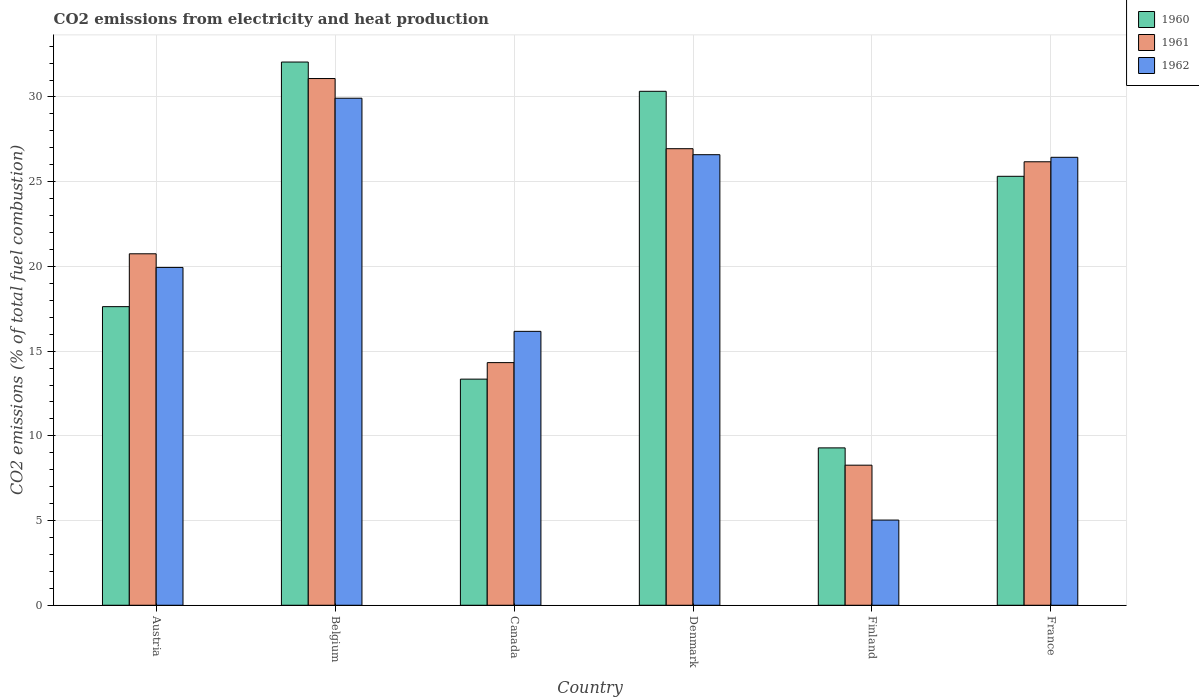How many groups of bars are there?
Make the answer very short. 6. Are the number of bars per tick equal to the number of legend labels?
Make the answer very short. Yes. How many bars are there on the 1st tick from the left?
Give a very brief answer. 3. How many bars are there on the 1st tick from the right?
Ensure brevity in your answer.  3. What is the amount of CO2 emitted in 1960 in Belgium?
Keep it short and to the point. 32.06. Across all countries, what is the maximum amount of CO2 emitted in 1962?
Offer a very short reply. 29.93. Across all countries, what is the minimum amount of CO2 emitted in 1960?
Provide a succinct answer. 9.29. What is the total amount of CO2 emitted in 1960 in the graph?
Offer a very short reply. 127.98. What is the difference between the amount of CO2 emitted in 1961 in Denmark and that in France?
Your answer should be very brief. 0.77. What is the difference between the amount of CO2 emitted in 1960 in Austria and the amount of CO2 emitted in 1961 in Belgium?
Give a very brief answer. -13.46. What is the average amount of CO2 emitted in 1962 per country?
Your response must be concise. 20.68. What is the difference between the amount of CO2 emitted of/in 1961 and amount of CO2 emitted of/in 1960 in Belgium?
Make the answer very short. -0.97. What is the ratio of the amount of CO2 emitted in 1960 in Canada to that in Finland?
Offer a terse response. 1.44. Is the amount of CO2 emitted in 1960 in Canada less than that in France?
Make the answer very short. Yes. What is the difference between the highest and the second highest amount of CO2 emitted in 1961?
Provide a succinct answer. 0.77. What is the difference between the highest and the lowest amount of CO2 emitted in 1961?
Offer a terse response. 22.82. What does the 1st bar from the left in Canada represents?
Your response must be concise. 1960. How many bars are there?
Your answer should be compact. 18. Are all the bars in the graph horizontal?
Your answer should be compact. No. Where does the legend appear in the graph?
Keep it short and to the point. Top right. How are the legend labels stacked?
Your answer should be very brief. Vertical. What is the title of the graph?
Offer a terse response. CO2 emissions from electricity and heat production. What is the label or title of the Y-axis?
Give a very brief answer. CO2 emissions (% of total fuel combustion). What is the CO2 emissions (% of total fuel combustion) in 1960 in Austria?
Provide a short and direct response. 17.63. What is the CO2 emissions (% of total fuel combustion) in 1961 in Austria?
Provide a short and direct response. 20.75. What is the CO2 emissions (% of total fuel combustion) of 1962 in Austria?
Ensure brevity in your answer.  19.94. What is the CO2 emissions (% of total fuel combustion) in 1960 in Belgium?
Ensure brevity in your answer.  32.06. What is the CO2 emissions (% of total fuel combustion) in 1961 in Belgium?
Give a very brief answer. 31.09. What is the CO2 emissions (% of total fuel combustion) of 1962 in Belgium?
Keep it short and to the point. 29.93. What is the CO2 emissions (% of total fuel combustion) in 1960 in Canada?
Your answer should be very brief. 13.35. What is the CO2 emissions (% of total fuel combustion) of 1961 in Canada?
Your response must be concise. 14.32. What is the CO2 emissions (% of total fuel combustion) in 1962 in Canada?
Your response must be concise. 16.17. What is the CO2 emissions (% of total fuel combustion) of 1960 in Denmark?
Provide a short and direct response. 30.34. What is the CO2 emissions (% of total fuel combustion) in 1961 in Denmark?
Give a very brief answer. 26.95. What is the CO2 emissions (% of total fuel combustion) of 1962 in Denmark?
Offer a terse response. 26.59. What is the CO2 emissions (% of total fuel combustion) in 1960 in Finland?
Offer a terse response. 9.29. What is the CO2 emissions (% of total fuel combustion) of 1961 in Finland?
Provide a succinct answer. 8.27. What is the CO2 emissions (% of total fuel combustion) of 1962 in Finland?
Ensure brevity in your answer.  5.03. What is the CO2 emissions (% of total fuel combustion) in 1960 in France?
Provide a succinct answer. 25.32. What is the CO2 emissions (% of total fuel combustion) of 1961 in France?
Offer a terse response. 26.18. What is the CO2 emissions (% of total fuel combustion) of 1962 in France?
Your answer should be compact. 26.44. Across all countries, what is the maximum CO2 emissions (% of total fuel combustion) of 1960?
Your response must be concise. 32.06. Across all countries, what is the maximum CO2 emissions (% of total fuel combustion) of 1961?
Your response must be concise. 31.09. Across all countries, what is the maximum CO2 emissions (% of total fuel combustion) in 1962?
Make the answer very short. 29.93. Across all countries, what is the minimum CO2 emissions (% of total fuel combustion) of 1960?
Keep it short and to the point. 9.29. Across all countries, what is the minimum CO2 emissions (% of total fuel combustion) in 1961?
Provide a short and direct response. 8.27. Across all countries, what is the minimum CO2 emissions (% of total fuel combustion) of 1962?
Your response must be concise. 5.03. What is the total CO2 emissions (% of total fuel combustion) in 1960 in the graph?
Your response must be concise. 127.98. What is the total CO2 emissions (% of total fuel combustion) in 1961 in the graph?
Offer a terse response. 127.55. What is the total CO2 emissions (% of total fuel combustion) in 1962 in the graph?
Offer a terse response. 124.1. What is the difference between the CO2 emissions (% of total fuel combustion) in 1960 in Austria and that in Belgium?
Your response must be concise. -14.44. What is the difference between the CO2 emissions (% of total fuel combustion) in 1961 in Austria and that in Belgium?
Your answer should be compact. -10.34. What is the difference between the CO2 emissions (% of total fuel combustion) in 1962 in Austria and that in Belgium?
Give a very brief answer. -9.99. What is the difference between the CO2 emissions (% of total fuel combustion) in 1960 in Austria and that in Canada?
Your answer should be compact. 4.28. What is the difference between the CO2 emissions (% of total fuel combustion) in 1961 in Austria and that in Canada?
Keep it short and to the point. 6.42. What is the difference between the CO2 emissions (% of total fuel combustion) in 1962 in Austria and that in Canada?
Ensure brevity in your answer.  3.77. What is the difference between the CO2 emissions (% of total fuel combustion) in 1960 in Austria and that in Denmark?
Give a very brief answer. -12.71. What is the difference between the CO2 emissions (% of total fuel combustion) in 1961 in Austria and that in Denmark?
Ensure brevity in your answer.  -6.2. What is the difference between the CO2 emissions (% of total fuel combustion) of 1962 in Austria and that in Denmark?
Your answer should be compact. -6.65. What is the difference between the CO2 emissions (% of total fuel combustion) in 1960 in Austria and that in Finland?
Make the answer very short. 8.34. What is the difference between the CO2 emissions (% of total fuel combustion) of 1961 in Austria and that in Finland?
Give a very brief answer. 12.48. What is the difference between the CO2 emissions (% of total fuel combustion) in 1962 in Austria and that in Finland?
Your answer should be compact. 14.91. What is the difference between the CO2 emissions (% of total fuel combustion) in 1960 in Austria and that in France?
Provide a succinct answer. -7.69. What is the difference between the CO2 emissions (% of total fuel combustion) of 1961 in Austria and that in France?
Keep it short and to the point. -5.43. What is the difference between the CO2 emissions (% of total fuel combustion) of 1962 in Austria and that in France?
Make the answer very short. -6.5. What is the difference between the CO2 emissions (% of total fuel combustion) of 1960 in Belgium and that in Canada?
Provide a succinct answer. 18.72. What is the difference between the CO2 emissions (% of total fuel combustion) in 1961 in Belgium and that in Canada?
Offer a very short reply. 16.77. What is the difference between the CO2 emissions (% of total fuel combustion) in 1962 in Belgium and that in Canada?
Provide a short and direct response. 13.76. What is the difference between the CO2 emissions (% of total fuel combustion) of 1960 in Belgium and that in Denmark?
Keep it short and to the point. 1.73. What is the difference between the CO2 emissions (% of total fuel combustion) in 1961 in Belgium and that in Denmark?
Keep it short and to the point. 4.14. What is the difference between the CO2 emissions (% of total fuel combustion) in 1962 in Belgium and that in Denmark?
Your response must be concise. 3.33. What is the difference between the CO2 emissions (% of total fuel combustion) of 1960 in Belgium and that in Finland?
Make the answer very short. 22.77. What is the difference between the CO2 emissions (% of total fuel combustion) in 1961 in Belgium and that in Finland?
Provide a short and direct response. 22.82. What is the difference between the CO2 emissions (% of total fuel combustion) of 1962 in Belgium and that in Finland?
Ensure brevity in your answer.  24.9. What is the difference between the CO2 emissions (% of total fuel combustion) of 1960 in Belgium and that in France?
Provide a succinct answer. 6.74. What is the difference between the CO2 emissions (% of total fuel combustion) in 1961 in Belgium and that in France?
Offer a terse response. 4.91. What is the difference between the CO2 emissions (% of total fuel combustion) in 1962 in Belgium and that in France?
Make the answer very short. 3.49. What is the difference between the CO2 emissions (% of total fuel combustion) of 1960 in Canada and that in Denmark?
Keep it short and to the point. -16.99. What is the difference between the CO2 emissions (% of total fuel combustion) in 1961 in Canada and that in Denmark?
Your response must be concise. -12.63. What is the difference between the CO2 emissions (% of total fuel combustion) in 1962 in Canada and that in Denmark?
Provide a short and direct response. -10.43. What is the difference between the CO2 emissions (% of total fuel combustion) of 1960 in Canada and that in Finland?
Give a very brief answer. 4.06. What is the difference between the CO2 emissions (% of total fuel combustion) of 1961 in Canada and that in Finland?
Make the answer very short. 6.05. What is the difference between the CO2 emissions (% of total fuel combustion) of 1962 in Canada and that in Finland?
Your answer should be compact. 11.14. What is the difference between the CO2 emissions (% of total fuel combustion) in 1960 in Canada and that in France?
Your response must be concise. -11.97. What is the difference between the CO2 emissions (% of total fuel combustion) in 1961 in Canada and that in France?
Your answer should be compact. -11.85. What is the difference between the CO2 emissions (% of total fuel combustion) in 1962 in Canada and that in France?
Your response must be concise. -10.27. What is the difference between the CO2 emissions (% of total fuel combustion) of 1960 in Denmark and that in Finland?
Your response must be concise. 21.05. What is the difference between the CO2 emissions (% of total fuel combustion) in 1961 in Denmark and that in Finland?
Make the answer very short. 18.68. What is the difference between the CO2 emissions (% of total fuel combustion) of 1962 in Denmark and that in Finland?
Offer a very short reply. 21.57. What is the difference between the CO2 emissions (% of total fuel combustion) of 1960 in Denmark and that in France?
Offer a terse response. 5.02. What is the difference between the CO2 emissions (% of total fuel combustion) of 1961 in Denmark and that in France?
Your answer should be very brief. 0.77. What is the difference between the CO2 emissions (% of total fuel combustion) of 1962 in Denmark and that in France?
Your answer should be compact. 0.15. What is the difference between the CO2 emissions (% of total fuel combustion) in 1960 in Finland and that in France?
Your answer should be compact. -16.03. What is the difference between the CO2 emissions (% of total fuel combustion) of 1961 in Finland and that in France?
Your answer should be very brief. -17.91. What is the difference between the CO2 emissions (% of total fuel combustion) of 1962 in Finland and that in France?
Ensure brevity in your answer.  -21.41. What is the difference between the CO2 emissions (% of total fuel combustion) of 1960 in Austria and the CO2 emissions (% of total fuel combustion) of 1961 in Belgium?
Give a very brief answer. -13.46. What is the difference between the CO2 emissions (% of total fuel combustion) of 1960 in Austria and the CO2 emissions (% of total fuel combustion) of 1962 in Belgium?
Give a very brief answer. -12.3. What is the difference between the CO2 emissions (% of total fuel combustion) in 1961 in Austria and the CO2 emissions (% of total fuel combustion) in 1962 in Belgium?
Keep it short and to the point. -9.18. What is the difference between the CO2 emissions (% of total fuel combustion) of 1960 in Austria and the CO2 emissions (% of total fuel combustion) of 1961 in Canada?
Your response must be concise. 3.3. What is the difference between the CO2 emissions (% of total fuel combustion) in 1960 in Austria and the CO2 emissions (% of total fuel combustion) in 1962 in Canada?
Make the answer very short. 1.46. What is the difference between the CO2 emissions (% of total fuel combustion) in 1961 in Austria and the CO2 emissions (% of total fuel combustion) in 1962 in Canada?
Keep it short and to the point. 4.58. What is the difference between the CO2 emissions (% of total fuel combustion) in 1960 in Austria and the CO2 emissions (% of total fuel combustion) in 1961 in Denmark?
Your answer should be compact. -9.32. What is the difference between the CO2 emissions (% of total fuel combustion) of 1960 in Austria and the CO2 emissions (% of total fuel combustion) of 1962 in Denmark?
Provide a short and direct response. -8.97. What is the difference between the CO2 emissions (% of total fuel combustion) in 1961 in Austria and the CO2 emissions (% of total fuel combustion) in 1962 in Denmark?
Your response must be concise. -5.85. What is the difference between the CO2 emissions (% of total fuel combustion) of 1960 in Austria and the CO2 emissions (% of total fuel combustion) of 1961 in Finland?
Offer a very short reply. 9.36. What is the difference between the CO2 emissions (% of total fuel combustion) in 1960 in Austria and the CO2 emissions (% of total fuel combustion) in 1962 in Finland?
Offer a terse response. 12.6. What is the difference between the CO2 emissions (% of total fuel combustion) of 1961 in Austria and the CO2 emissions (% of total fuel combustion) of 1962 in Finland?
Make the answer very short. 15.72. What is the difference between the CO2 emissions (% of total fuel combustion) of 1960 in Austria and the CO2 emissions (% of total fuel combustion) of 1961 in France?
Your answer should be compact. -8.55. What is the difference between the CO2 emissions (% of total fuel combustion) in 1960 in Austria and the CO2 emissions (% of total fuel combustion) in 1962 in France?
Give a very brief answer. -8.81. What is the difference between the CO2 emissions (% of total fuel combustion) of 1961 in Austria and the CO2 emissions (% of total fuel combustion) of 1962 in France?
Make the answer very short. -5.69. What is the difference between the CO2 emissions (% of total fuel combustion) in 1960 in Belgium and the CO2 emissions (% of total fuel combustion) in 1961 in Canada?
Keep it short and to the point. 17.74. What is the difference between the CO2 emissions (% of total fuel combustion) in 1960 in Belgium and the CO2 emissions (% of total fuel combustion) in 1962 in Canada?
Ensure brevity in your answer.  15.9. What is the difference between the CO2 emissions (% of total fuel combustion) of 1961 in Belgium and the CO2 emissions (% of total fuel combustion) of 1962 in Canada?
Offer a terse response. 14.92. What is the difference between the CO2 emissions (% of total fuel combustion) in 1960 in Belgium and the CO2 emissions (% of total fuel combustion) in 1961 in Denmark?
Your response must be concise. 5.11. What is the difference between the CO2 emissions (% of total fuel combustion) of 1960 in Belgium and the CO2 emissions (% of total fuel combustion) of 1962 in Denmark?
Your response must be concise. 5.47. What is the difference between the CO2 emissions (% of total fuel combustion) of 1961 in Belgium and the CO2 emissions (% of total fuel combustion) of 1962 in Denmark?
Your answer should be compact. 4.5. What is the difference between the CO2 emissions (% of total fuel combustion) in 1960 in Belgium and the CO2 emissions (% of total fuel combustion) in 1961 in Finland?
Your answer should be compact. 23.79. What is the difference between the CO2 emissions (% of total fuel combustion) of 1960 in Belgium and the CO2 emissions (% of total fuel combustion) of 1962 in Finland?
Give a very brief answer. 27.04. What is the difference between the CO2 emissions (% of total fuel combustion) of 1961 in Belgium and the CO2 emissions (% of total fuel combustion) of 1962 in Finland?
Ensure brevity in your answer.  26.06. What is the difference between the CO2 emissions (% of total fuel combustion) of 1960 in Belgium and the CO2 emissions (% of total fuel combustion) of 1961 in France?
Your answer should be very brief. 5.89. What is the difference between the CO2 emissions (% of total fuel combustion) of 1960 in Belgium and the CO2 emissions (% of total fuel combustion) of 1962 in France?
Provide a succinct answer. 5.62. What is the difference between the CO2 emissions (% of total fuel combustion) of 1961 in Belgium and the CO2 emissions (% of total fuel combustion) of 1962 in France?
Your response must be concise. 4.65. What is the difference between the CO2 emissions (% of total fuel combustion) of 1960 in Canada and the CO2 emissions (% of total fuel combustion) of 1961 in Denmark?
Offer a terse response. -13.6. What is the difference between the CO2 emissions (% of total fuel combustion) in 1960 in Canada and the CO2 emissions (% of total fuel combustion) in 1962 in Denmark?
Provide a short and direct response. -13.25. What is the difference between the CO2 emissions (% of total fuel combustion) in 1961 in Canada and the CO2 emissions (% of total fuel combustion) in 1962 in Denmark?
Give a very brief answer. -12.27. What is the difference between the CO2 emissions (% of total fuel combustion) in 1960 in Canada and the CO2 emissions (% of total fuel combustion) in 1961 in Finland?
Your answer should be very brief. 5.08. What is the difference between the CO2 emissions (% of total fuel combustion) in 1960 in Canada and the CO2 emissions (% of total fuel combustion) in 1962 in Finland?
Offer a very short reply. 8.32. What is the difference between the CO2 emissions (% of total fuel combustion) in 1961 in Canada and the CO2 emissions (% of total fuel combustion) in 1962 in Finland?
Your response must be concise. 9.29. What is the difference between the CO2 emissions (% of total fuel combustion) of 1960 in Canada and the CO2 emissions (% of total fuel combustion) of 1961 in France?
Provide a succinct answer. -12.83. What is the difference between the CO2 emissions (% of total fuel combustion) in 1960 in Canada and the CO2 emissions (% of total fuel combustion) in 1962 in France?
Your response must be concise. -13.09. What is the difference between the CO2 emissions (% of total fuel combustion) in 1961 in Canada and the CO2 emissions (% of total fuel combustion) in 1962 in France?
Your response must be concise. -12.12. What is the difference between the CO2 emissions (% of total fuel combustion) of 1960 in Denmark and the CO2 emissions (% of total fuel combustion) of 1961 in Finland?
Your answer should be compact. 22.07. What is the difference between the CO2 emissions (% of total fuel combustion) in 1960 in Denmark and the CO2 emissions (% of total fuel combustion) in 1962 in Finland?
Your response must be concise. 25.31. What is the difference between the CO2 emissions (% of total fuel combustion) in 1961 in Denmark and the CO2 emissions (% of total fuel combustion) in 1962 in Finland?
Provide a short and direct response. 21.92. What is the difference between the CO2 emissions (% of total fuel combustion) of 1960 in Denmark and the CO2 emissions (% of total fuel combustion) of 1961 in France?
Offer a very short reply. 4.16. What is the difference between the CO2 emissions (% of total fuel combustion) in 1960 in Denmark and the CO2 emissions (% of total fuel combustion) in 1962 in France?
Your answer should be very brief. 3.9. What is the difference between the CO2 emissions (% of total fuel combustion) in 1961 in Denmark and the CO2 emissions (% of total fuel combustion) in 1962 in France?
Offer a very short reply. 0.51. What is the difference between the CO2 emissions (% of total fuel combustion) of 1960 in Finland and the CO2 emissions (% of total fuel combustion) of 1961 in France?
Provide a short and direct response. -16.89. What is the difference between the CO2 emissions (% of total fuel combustion) in 1960 in Finland and the CO2 emissions (% of total fuel combustion) in 1962 in France?
Your answer should be compact. -17.15. What is the difference between the CO2 emissions (% of total fuel combustion) of 1961 in Finland and the CO2 emissions (% of total fuel combustion) of 1962 in France?
Ensure brevity in your answer.  -18.17. What is the average CO2 emissions (% of total fuel combustion) of 1960 per country?
Provide a succinct answer. 21.33. What is the average CO2 emissions (% of total fuel combustion) of 1961 per country?
Offer a very short reply. 21.26. What is the average CO2 emissions (% of total fuel combustion) in 1962 per country?
Provide a succinct answer. 20.68. What is the difference between the CO2 emissions (% of total fuel combustion) of 1960 and CO2 emissions (% of total fuel combustion) of 1961 in Austria?
Offer a very short reply. -3.12. What is the difference between the CO2 emissions (% of total fuel combustion) in 1960 and CO2 emissions (% of total fuel combustion) in 1962 in Austria?
Your answer should be compact. -2.31. What is the difference between the CO2 emissions (% of total fuel combustion) in 1961 and CO2 emissions (% of total fuel combustion) in 1962 in Austria?
Provide a succinct answer. 0.81. What is the difference between the CO2 emissions (% of total fuel combustion) in 1960 and CO2 emissions (% of total fuel combustion) in 1961 in Belgium?
Make the answer very short. 0.97. What is the difference between the CO2 emissions (% of total fuel combustion) in 1960 and CO2 emissions (% of total fuel combustion) in 1962 in Belgium?
Make the answer very short. 2.14. What is the difference between the CO2 emissions (% of total fuel combustion) in 1961 and CO2 emissions (% of total fuel combustion) in 1962 in Belgium?
Your response must be concise. 1.16. What is the difference between the CO2 emissions (% of total fuel combustion) of 1960 and CO2 emissions (% of total fuel combustion) of 1961 in Canada?
Keep it short and to the point. -0.98. What is the difference between the CO2 emissions (% of total fuel combustion) of 1960 and CO2 emissions (% of total fuel combustion) of 1962 in Canada?
Your response must be concise. -2.82. What is the difference between the CO2 emissions (% of total fuel combustion) in 1961 and CO2 emissions (% of total fuel combustion) in 1962 in Canada?
Your answer should be very brief. -1.85. What is the difference between the CO2 emissions (% of total fuel combustion) of 1960 and CO2 emissions (% of total fuel combustion) of 1961 in Denmark?
Your answer should be very brief. 3.39. What is the difference between the CO2 emissions (% of total fuel combustion) in 1960 and CO2 emissions (% of total fuel combustion) in 1962 in Denmark?
Keep it short and to the point. 3.74. What is the difference between the CO2 emissions (% of total fuel combustion) of 1961 and CO2 emissions (% of total fuel combustion) of 1962 in Denmark?
Your answer should be compact. 0.35. What is the difference between the CO2 emissions (% of total fuel combustion) in 1960 and CO2 emissions (% of total fuel combustion) in 1961 in Finland?
Offer a terse response. 1.02. What is the difference between the CO2 emissions (% of total fuel combustion) of 1960 and CO2 emissions (% of total fuel combustion) of 1962 in Finland?
Offer a very short reply. 4.26. What is the difference between the CO2 emissions (% of total fuel combustion) of 1961 and CO2 emissions (% of total fuel combustion) of 1962 in Finland?
Offer a terse response. 3.24. What is the difference between the CO2 emissions (% of total fuel combustion) of 1960 and CO2 emissions (% of total fuel combustion) of 1961 in France?
Offer a very short reply. -0.86. What is the difference between the CO2 emissions (% of total fuel combustion) in 1960 and CO2 emissions (% of total fuel combustion) in 1962 in France?
Offer a terse response. -1.12. What is the difference between the CO2 emissions (% of total fuel combustion) in 1961 and CO2 emissions (% of total fuel combustion) in 1962 in France?
Give a very brief answer. -0.26. What is the ratio of the CO2 emissions (% of total fuel combustion) in 1960 in Austria to that in Belgium?
Provide a short and direct response. 0.55. What is the ratio of the CO2 emissions (% of total fuel combustion) of 1961 in Austria to that in Belgium?
Ensure brevity in your answer.  0.67. What is the ratio of the CO2 emissions (% of total fuel combustion) in 1962 in Austria to that in Belgium?
Provide a short and direct response. 0.67. What is the ratio of the CO2 emissions (% of total fuel combustion) in 1960 in Austria to that in Canada?
Your answer should be very brief. 1.32. What is the ratio of the CO2 emissions (% of total fuel combustion) in 1961 in Austria to that in Canada?
Provide a short and direct response. 1.45. What is the ratio of the CO2 emissions (% of total fuel combustion) in 1962 in Austria to that in Canada?
Provide a short and direct response. 1.23. What is the ratio of the CO2 emissions (% of total fuel combustion) in 1960 in Austria to that in Denmark?
Offer a terse response. 0.58. What is the ratio of the CO2 emissions (% of total fuel combustion) in 1961 in Austria to that in Denmark?
Ensure brevity in your answer.  0.77. What is the ratio of the CO2 emissions (% of total fuel combustion) in 1962 in Austria to that in Denmark?
Make the answer very short. 0.75. What is the ratio of the CO2 emissions (% of total fuel combustion) of 1960 in Austria to that in Finland?
Your response must be concise. 1.9. What is the ratio of the CO2 emissions (% of total fuel combustion) in 1961 in Austria to that in Finland?
Provide a succinct answer. 2.51. What is the ratio of the CO2 emissions (% of total fuel combustion) in 1962 in Austria to that in Finland?
Give a very brief answer. 3.97. What is the ratio of the CO2 emissions (% of total fuel combustion) of 1960 in Austria to that in France?
Offer a very short reply. 0.7. What is the ratio of the CO2 emissions (% of total fuel combustion) of 1961 in Austria to that in France?
Make the answer very short. 0.79. What is the ratio of the CO2 emissions (% of total fuel combustion) in 1962 in Austria to that in France?
Provide a succinct answer. 0.75. What is the ratio of the CO2 emissions (% of total fuel combustion) in 1960 in Belgium to that in Canada?
Ensure brevity in your answer.  2.4. What is the ratio of the CO2 emissions (% of total fuel combustion) in 1961 in Belgium to that in Canada?
Offer a terse response. 2.17. What is the ratio of the CO2 emissions (% of total fuel combustion) of 1962 in Belgium to that in Canada?
Offer a terse response. 1.85. What is the ratio of the CO2 emissions (% of total fuel combustion) of 1960 in Belgium to that in Denmark?
Keep it short and to the point. 1.06. What is the ratio of the CO2 emissions (% of total fuel combustion) of 1961 in Belgium to that in Denmark?
Your answer should be very brief. 1.15. What is the ratio of the CO2 emissions (% of total fuel combustion) in 1962 in Belgium to that in Denmark?
Your answer should be very brief. 1.13. What is the ratio of the CO2 emissions (% of total fuel combustion) in 1960 in Belgium to that in Finland?
Your response must be concise. 3.45. What is the ratio of the CO2 emissions (% of total fuel combustion) of 1961 in Belgium to that in Finland?
Your response must be concise. 3.76. What is the ratio of the CO2 emissions (% of total fuel combustion) in 1962 in Belgium to that in Finland?
Offer a very short reply. 5.95. What is the ratio of the CO2 emissions (% of total fuel combustion) of 1960 in Belgium to that in France?
Your answer should be very brief. 1.27. What is the ratio of the CO2 emissions (% of total fuel combustion) of 1961 in Belgium to that in France?
Give a very brief answer. 1.19. What is the ratio of the CO2 emissions (% of total fuel combustion) of 1962 in Belgium to that in France?
Your answer should be very brief. 1.13. What is the ratio of the CO2 emissions (% of total fuel combustion) of 1960 in Canada to that in Denmark?
Your answer should be very brief. 0.44. What is the ratio of the CO2 emissions (% of total fuel combustion) in 1961 in Canada to that in Denmark?
Your answer should be very brief. 0.53. What is the ratio of the CO2 emissions (% of total fuel combustion) in 1962 in Canada to that in Denmark?
Ensure brevity in your answer.  0.61. What is the ratio of the CO2 emissions (% of total fuel combustion) of 1960 in Canada to that in Finland?
Your answer should be very brief. 1.44. What is the ratio of the CO2 emissions (% of total fuel combustion) in 1961 in Canada to that in Finland?
Keep it short and to the point. 1.73. What is the ratio of the CO2 emissions (% of total fuel combustion) of 1962 in Canada to that in Finland?
Give a very brief answer. 3.22. What is the ratio of the CO2 emissions (% of total fuel combustion) in 1960 in Canada to that in France?
Your answer should be very brief. 0.53. What is the ratio of the CO2 emissions (% of total fuel combustion) in 1961 in Canada to that in France?
Your answer should be very brief. 0.55. What is the ratio of the CO2 emissions (% of total fuel combustion) in 1962 in Canada to that in France?
Keep it short and to the point. 0.61. What is the ratio of the CO2 emissions (% of total fuel combustion) of 1960 in Denmark to that in Finland?
Ensure brevity in your answer.  3.27. What is the ratio of the CO2 emissions (% of total fuel combustion) of 1961 in Denmark to that in Finland?
Ensure brevity in your answer.  3.26. What is the ratio of the CO2 emissions (% of total fuel combustion) of 1962 in Denmark to that in Finland?
Ensure brevity in your answer.  5.29. What is the ratio of the CO2 emissions (% of total fuel combustion) in 1960 in Denmark to that in France?
Provide a short and direct response. 1.2. What is the ratio of the CO2 emissions (% of total fuel combustion) in 1961 in Denmark to that in France?
Your answer should be compact. 1.03. What is the ratio of the CO2 emissions (% of total fuel combustion) in 1960 in Finland to that in France?
Offer a very short reply. 0.37. What is the ratio of the CO2 emissions (% of total fuel combustion) in 1961 in Finland to that in France?
Make the answer very short. 0.32. What is the ratio of the CO2 emissions (% of total fuel combustion) of 1962 in Finland to that in France?
Your response must be concise. 0.19. What is the difference between the highest and the second highest CO2 emissions (% of total fuel combustion) of 1960?
Provide a succinct answer. 1.73. What is the difference between the highest and the second highest CO2 emissions (% of total fuel combustion) of 1961?
Offer a terse response. 4.14. What is the difference between the highest and the second highest CO2 emissions (% of total fuel combustion) of 1962?
Your answer should be compact. 3.33. What is the difference between the highest and the lowest CO2 emissions (% of total fuel combustion) of 1960?
Provide a short and direct response. 22.77. What is the difference between the highest and the lowest CO2 emissions (% of total fuel combustion) of 1961?
Make the answer very short. 22.82. What is the difference between the highest and the lowest CO2 emissions (% of total fuel combustion) of 1962?
Provide a short and direct response. 24.9. 